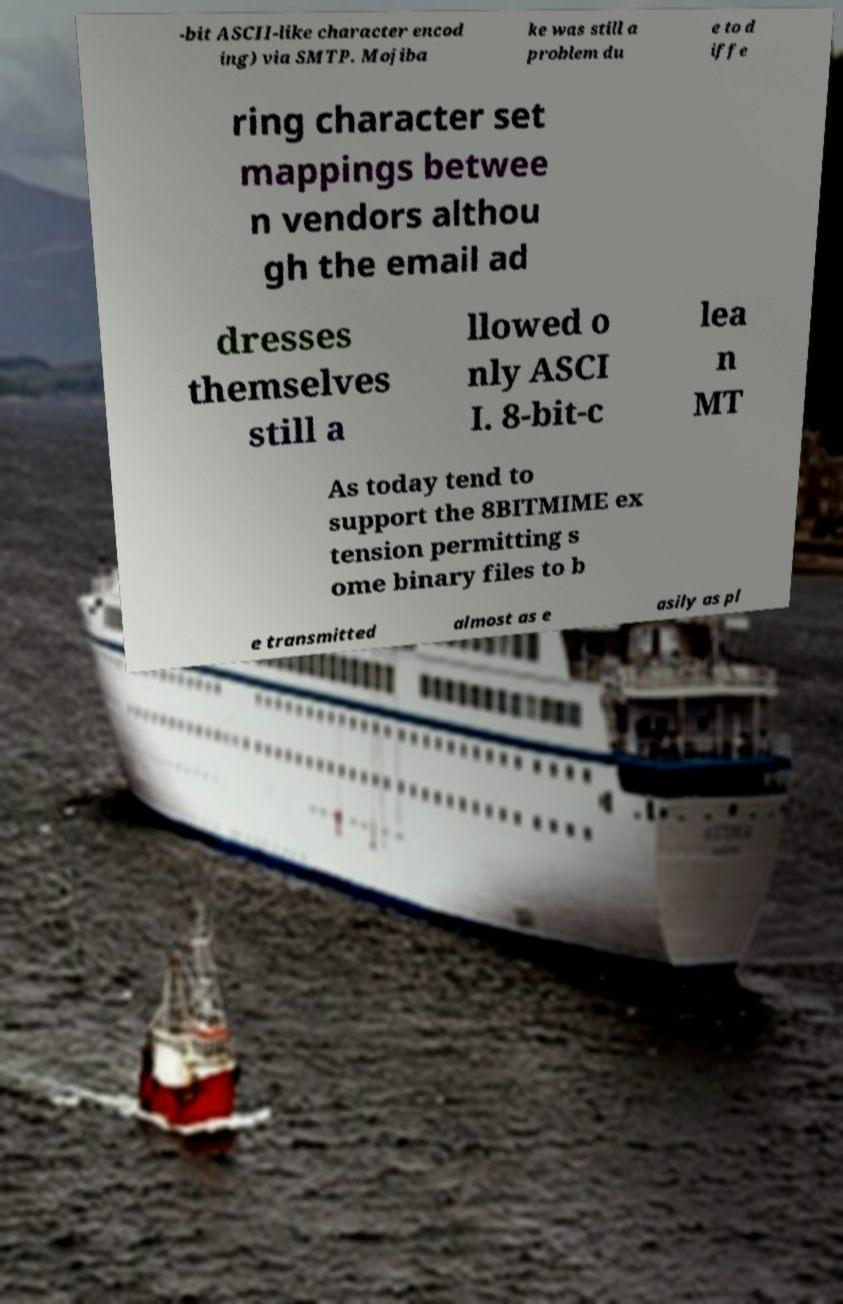Please read and relay the text visible in this image. What does it say? -bit ASCII-like character encod ing) via SMTP. Mojiba ke was still a problem du e to d iffe ring character set mappings betwee n vendors althou gh the email ad dresses themselves still a llowed o nly ASCI I. 8-bit-c lea n MT As today tend to support the 8BITMIME ex tension permitting s ome binary files to b e transmitted almost as e asily as pl 